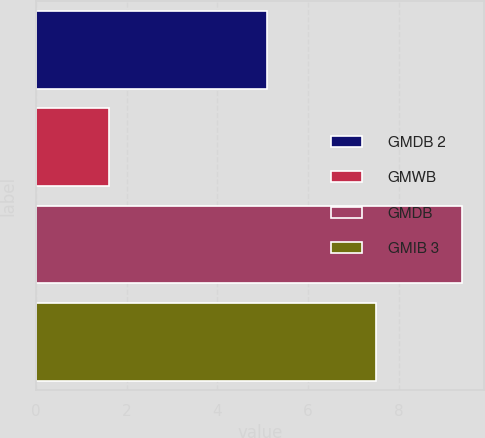Convert chart to OTSL. <chart><loc_0><loc_0><loc_500><loc_500><bar_chart><fcel>GMDB 2<fcel>GMWB<fcel>GMDB<fcel>GMIB 3<nl><fcel>5.1<fcel>1.6<fcel>9.4<fcel>7.5<nl></chart> 